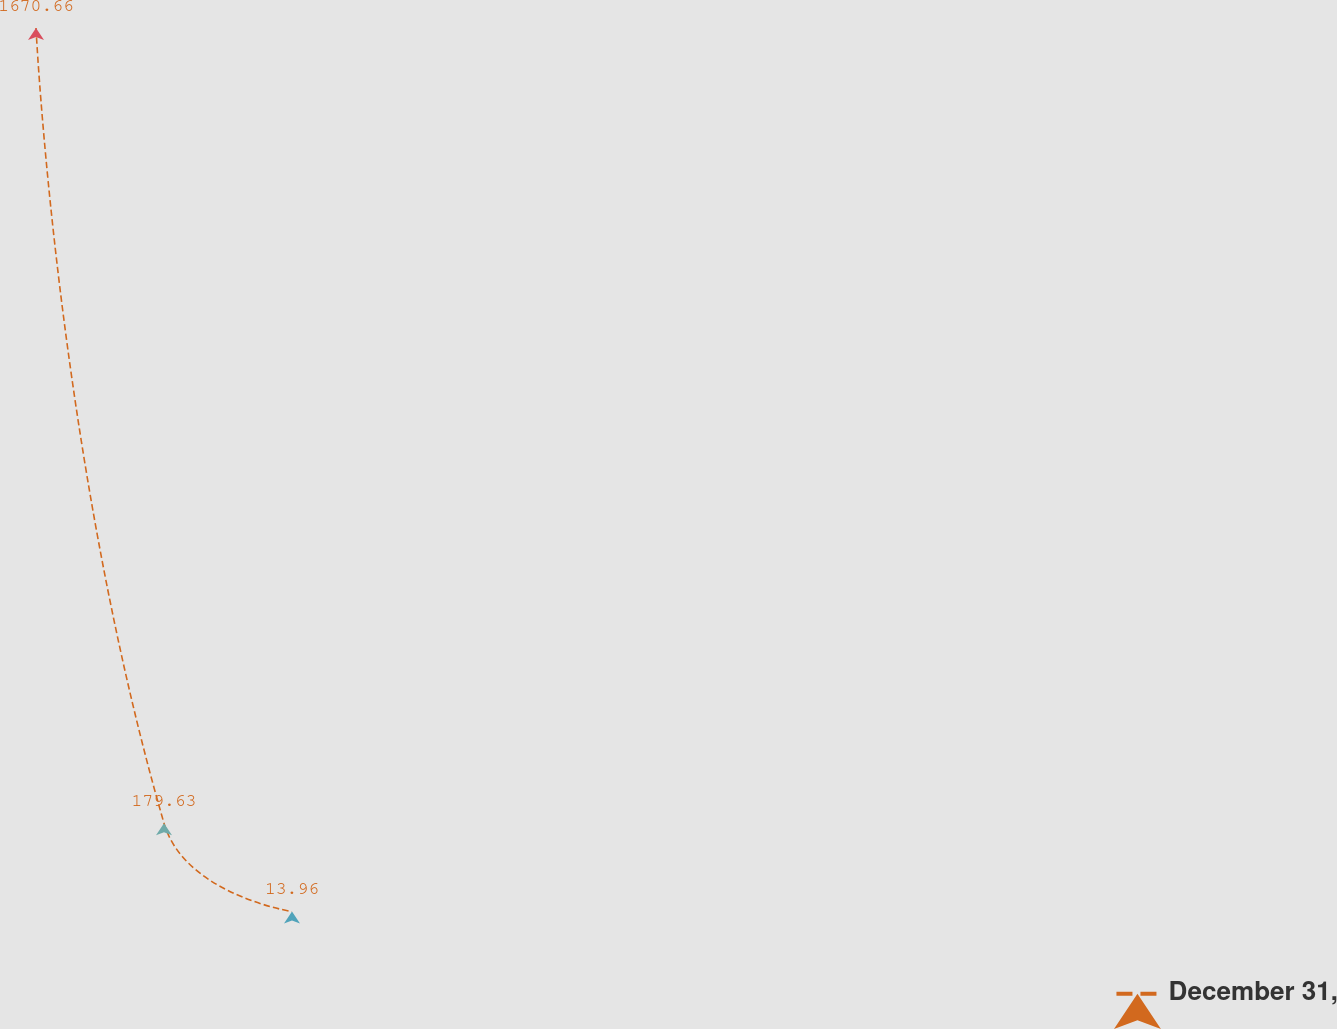Convert chart. <chart><loc_0><loc_0><loc_500><loc_500><line_chart><ecel><fcel>December 31,<nl><fcel>20.8<fcel>1670.66<nl><fcel>193.74<fcel>179.63<nl><fcel>366.68<fcel>13.96<nl><fcel>1750.23<fcel>345.3<nl></chart> 